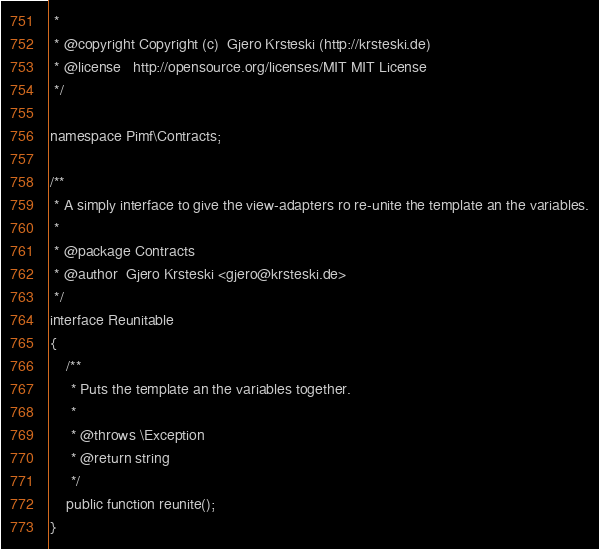<code> <loc_0><loc_0><loc_500><loc_500><_PHP_> *
 * @copyright Copyright (c)  Gjero Krsteski (http://krsteski.de)
 * @license   http://opensource.org/licenses/MIT MIT License
 */

namespace Pimf\Contracts;

/**
 * A simply interface to give the view-adapters ro re-unite the template an the variables.
 *
 * @package Contracts
 * @author  Gjero Krsteski <gjero@krsteski.de>
 */
interface Reunitable
{
    /**
     * Puts the template an the variables together.
     *
     * @throws \Exception
     * @return string
     */
    public function reunite();
}
</code> 